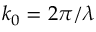Convert formula to latex. <formula><loc_0><loc_0><loc_500><loc_500>k _ { 0 } = 2 \pi / \lambda</formula> 